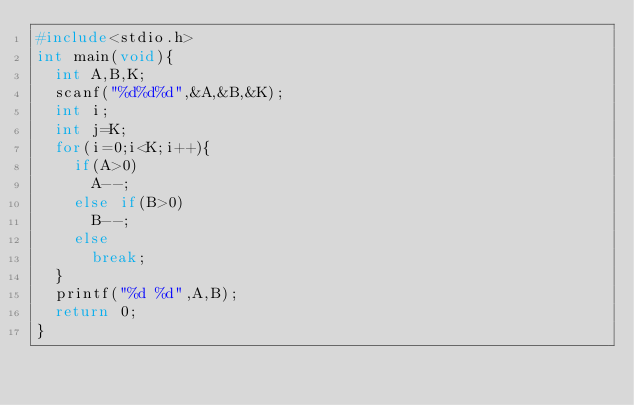Convert code to text. <code><loc_0><loc_0><loc_500><loc_500><_C_>#include<stdio.h>
int main(void){
  int A,B,K;
  scanf("%d%d%d",&A,&B,&K);
  int i;
  int j=K;
  for(i=0;i<K;i++){
    if(A>0)
      A--;
    else if(B>0)
      B--;
    else
      break;
  }
  printf("%d %d",A,B);
  return 0;
}
     </code> 